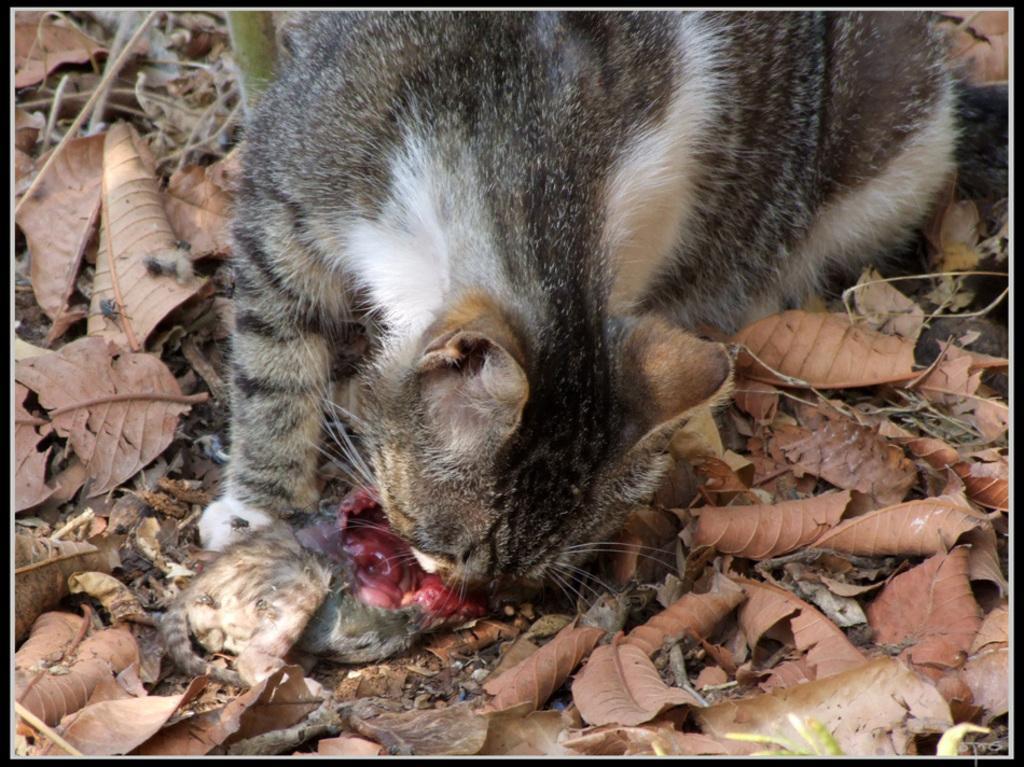How would you summarize this image in a sentence or two? In the image there is a cat which is in black and white color. It is eating an animal which is on the ground. And also there are dry leaves on the ground. 